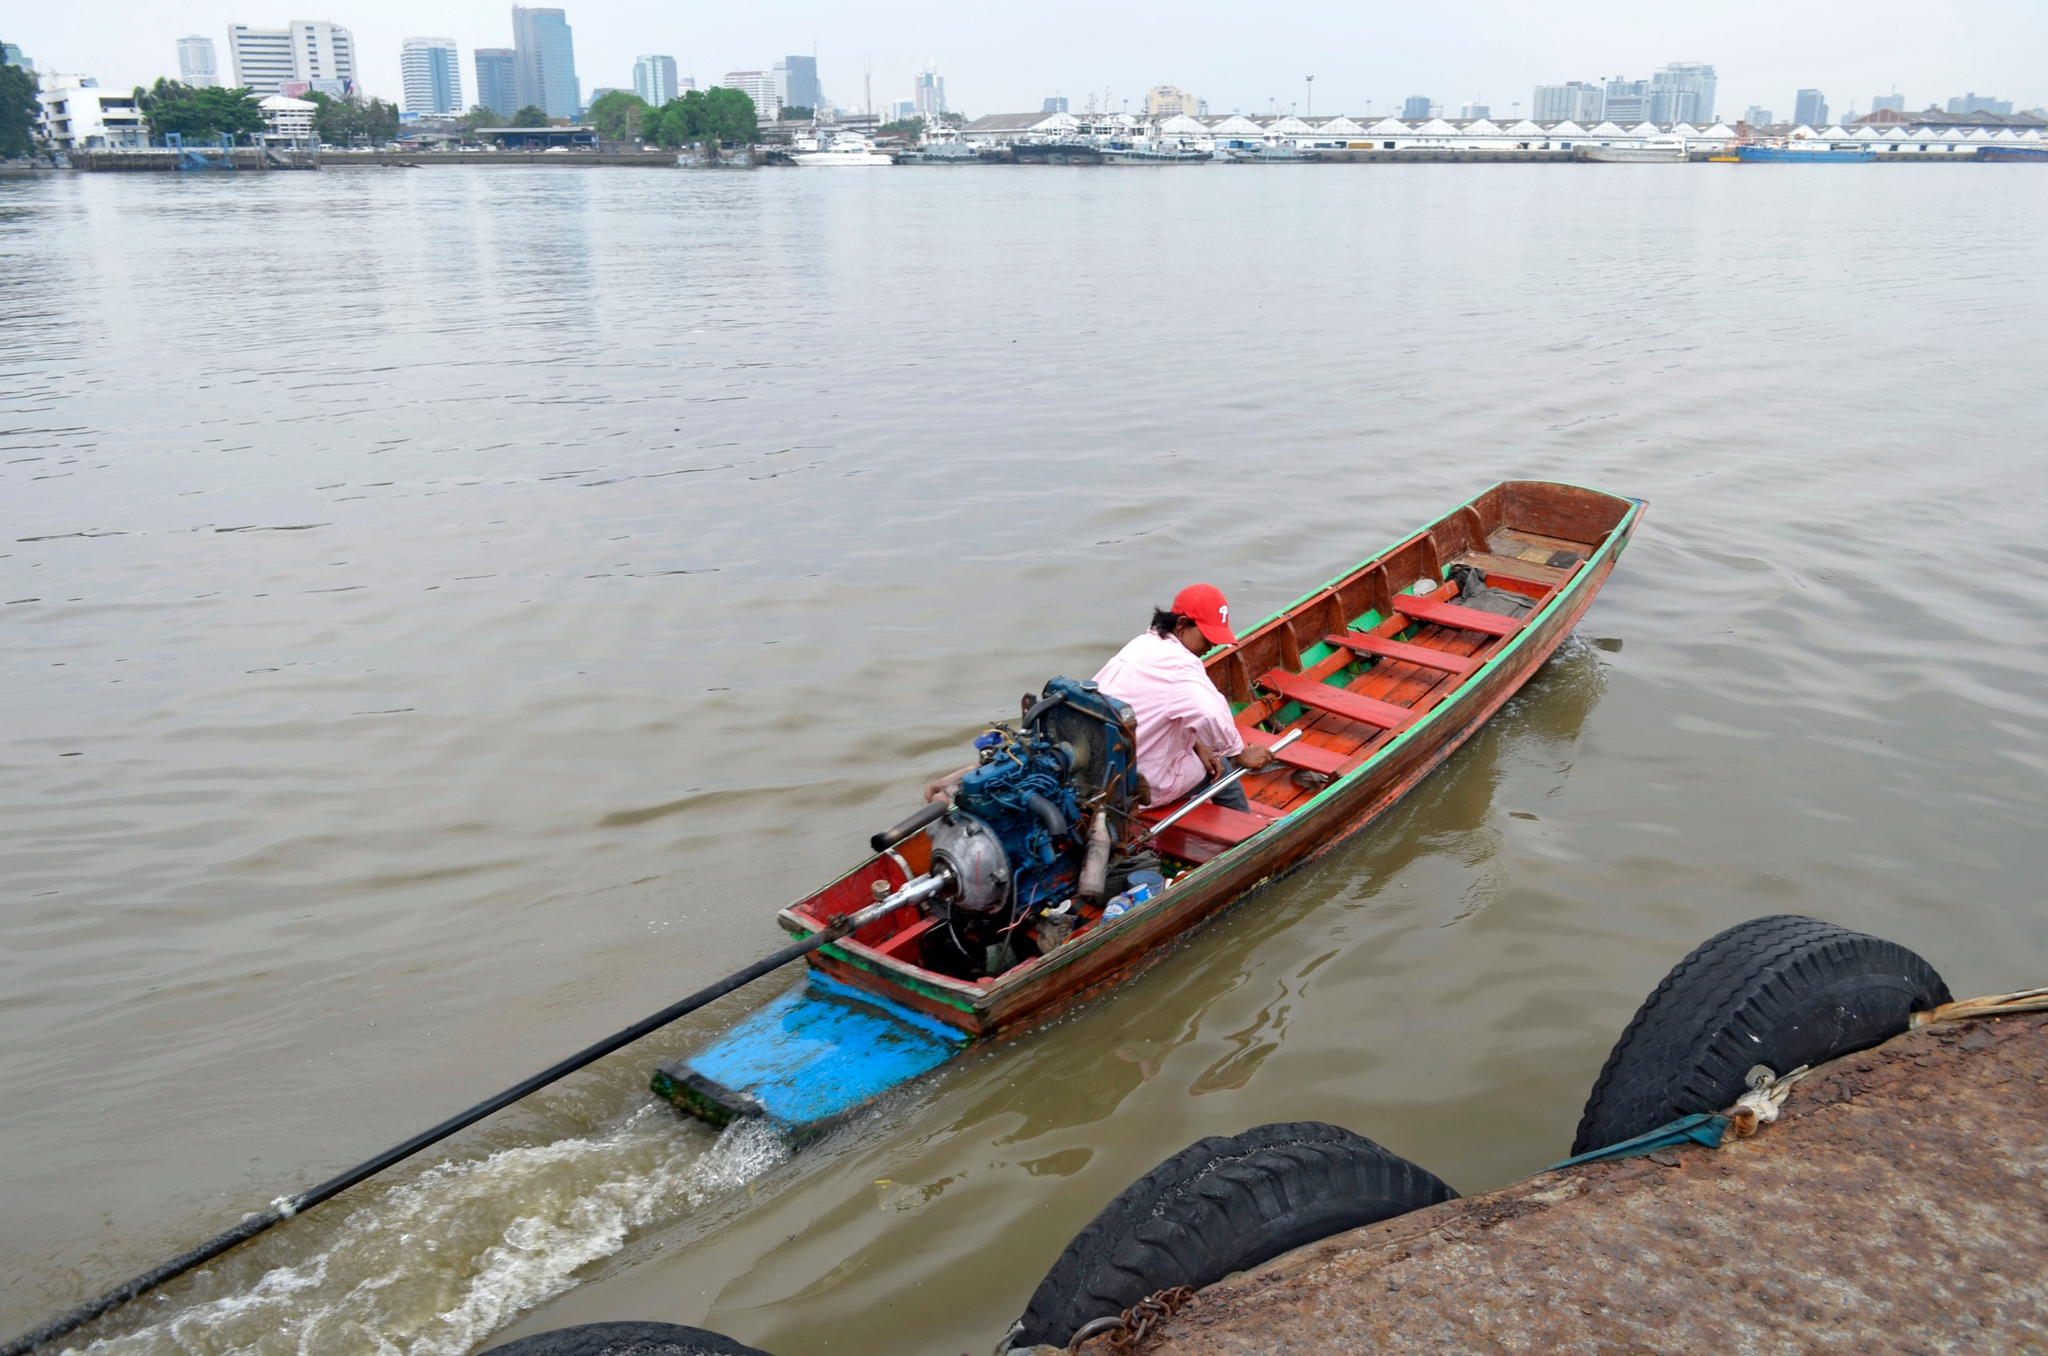What kind of wildlife might someone see while navigating this river? While navigating this river, one might spot various types of wildlife, particularly if the areas around the river are rich in biodiversity. Birds like herons, kingfishers, and ducks might be commonly seen flying overhead or perched near the water. In the water itself, fish such as catfish, carp, or trout could be visible, especially near quieter, undisturbed sections of the river. Occasionally, one might even spot turtles basking on rocks or logs along the river’s edge. The presence of urban structures in the background suggests that the river is close to a city, so the wildlife might also include animals adapted to both aquatic and urban environments, such as certain species of amphibians or small mammals like otters. 